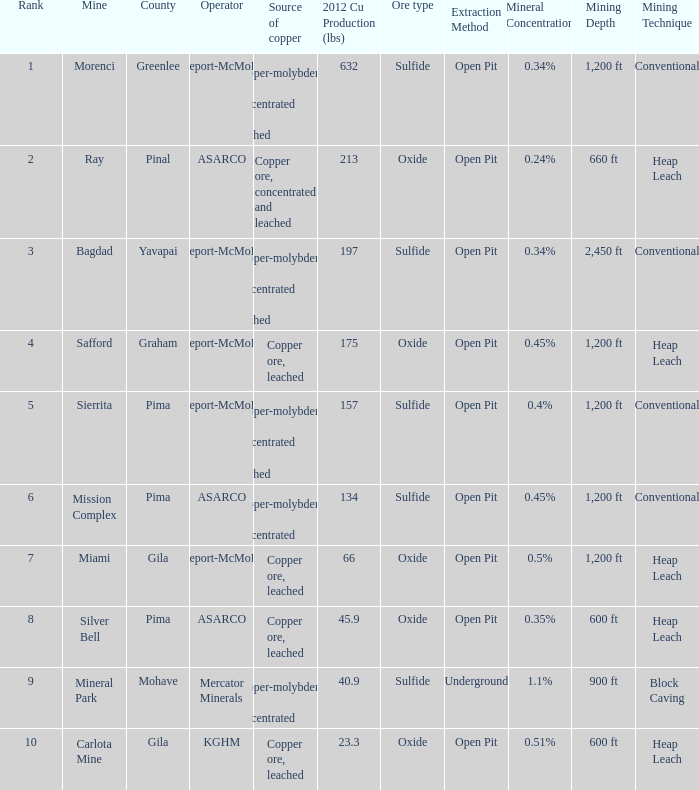Which operator has a rank of 7? Freeport-McMoRan. 